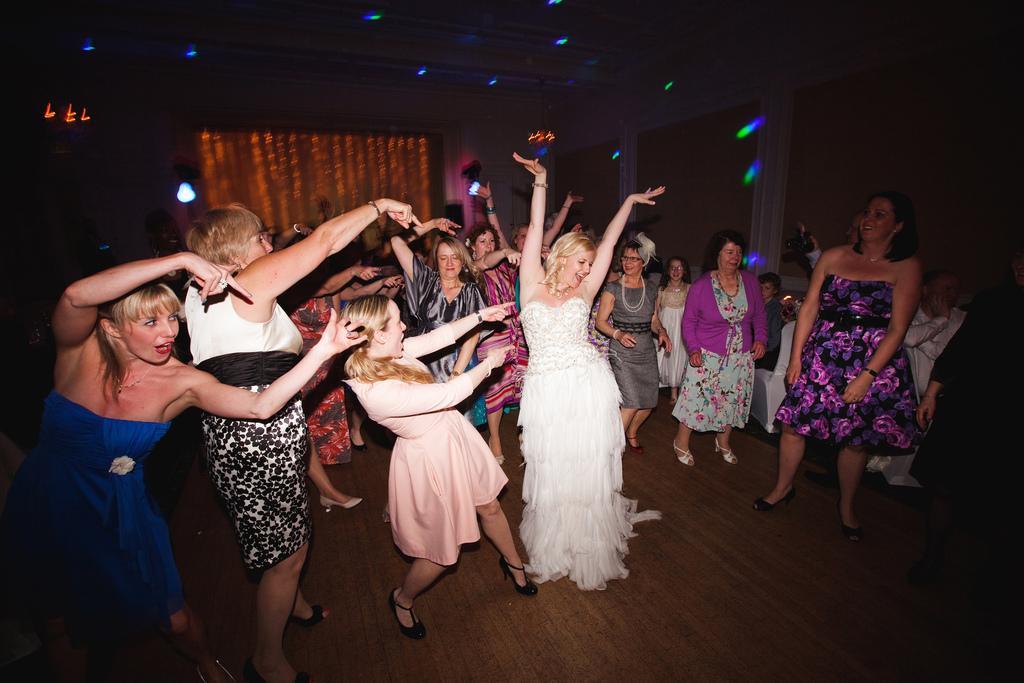In one or two sentences, can you explain what this image depicts? In this image I can see there are group of women dancing on floor and they are wearing a colorful dress and at the top I can see colorful lights and a curtain in the background and beams visible in the middle. 